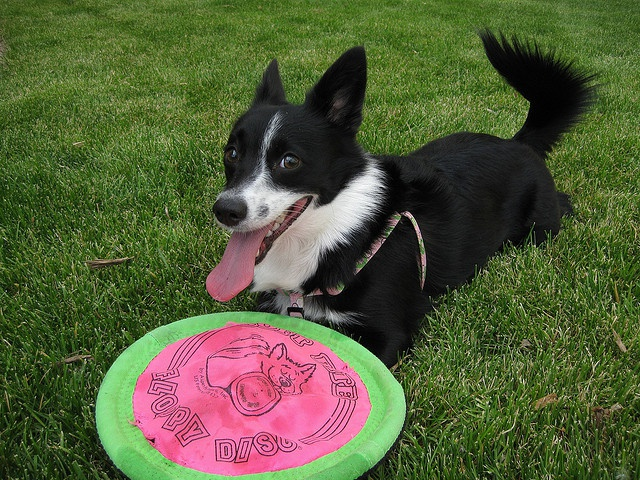Describe the objects in this image and their specific colors. I can see dog in darkgreen, black, darkgray, gray, and lightgray tones and frisbee in darkgreen, violet, lightgreen, and lightpink tones in this image. 